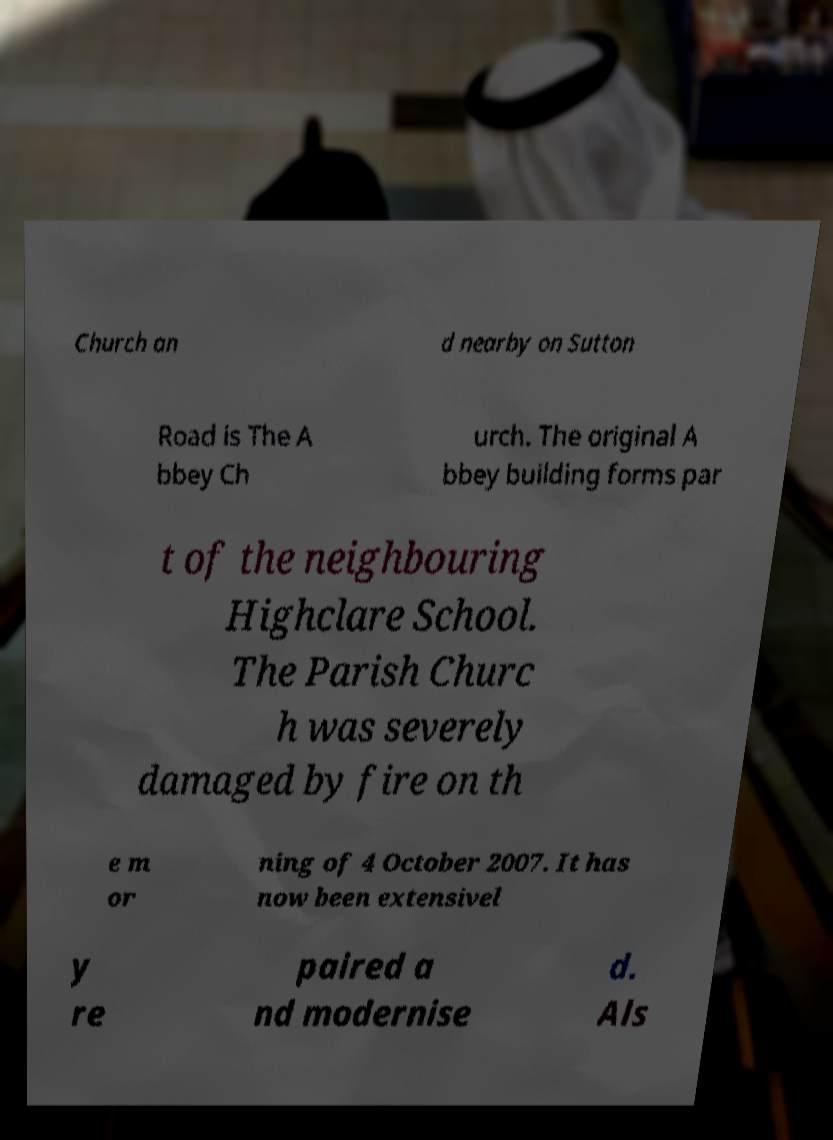For documentation purposes, I need the text within this image transcribed. Could you provide that? Church an d nearby on Sutton Road is The A bbey Ch urch. The original A bbey building forms par t of the neighbouring Highclare School. The Parish Churc h was severely damaged by fire on th e m or ning of 4 October 2007. It has now been extensivel y re paired a nd modernise d. Als 